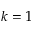Convert formula to latex. <formula><loc_0><loc_0><loc_500><loc_500>k = 1</formula> 